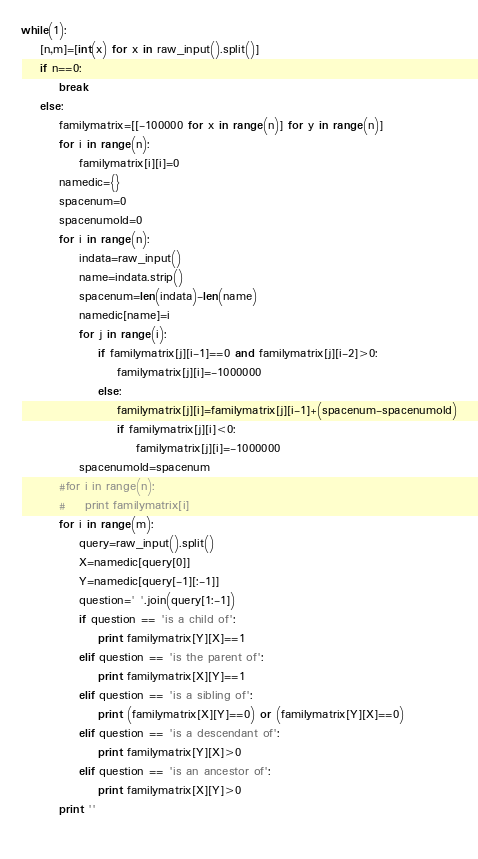Convert code to text. <code><loc_0><loc_0><loc_500><loc_500><_Python_>while(1):
    [n,m]=[int(x) for x in raw_input().split()]
    if n==0:
        break
    else:
        familymatrix=[[-100000 for x in range(n)] for y in range(n)]
        for i in range(n):
            familymatrix[i][i]=0
        namedic={}
        spacenum=0
        spacenumold=0
        for i in range(n):
            indata=raw_input()
            name=indata.strip()
            spacenum=len(indata)-len(name)
            namedic[name]=i
            for j in range(i):
                if familymatrix[j][i-1]==0 and familymatrix[j][i-2]>0:
                    familymatrix[j][i]=-1000000
                else:
                    familymatrix[j][i]=familymatrix[j][i-1]+(spacenum-spacenumold)
                    if familymatrix[j][i]<0:
                        familymatrix[j][i]=-1000000
            spacenumold=spacenum
        #for i in range(n):
        #    print familymatrix[i]
        for i in range(m):
            query=raw_input().split()
            X=namedic[query[0]]
            Y=namedic[query[-1][:-1]]
            question=' '.join(query[1:-1])
            if question == 'is a child of':
                print familymatrix[Y][X]==1
            elif question == 'is the parent of':
                print familymatrix[X][Y]==1
            elif question == 'is a sibling of':
                print (familymatrix[X][Y]==0) or (familymatrix[Y][X]==0)
            elif question == 'is a descendant of':
                print familymatrix[Y][X]>0
            elif question == 'is an ancestor of':
                print familymatrix[X][Y]>0
        print ''
        </code> 